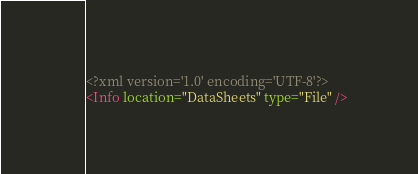Convert code to text. <code><loc_0><loc_0><loc_500><loc_500><_XML_><?xml version='1.0' encoding='UTF-8'?>
<Info location="DataSheets" type="File" /></code> 